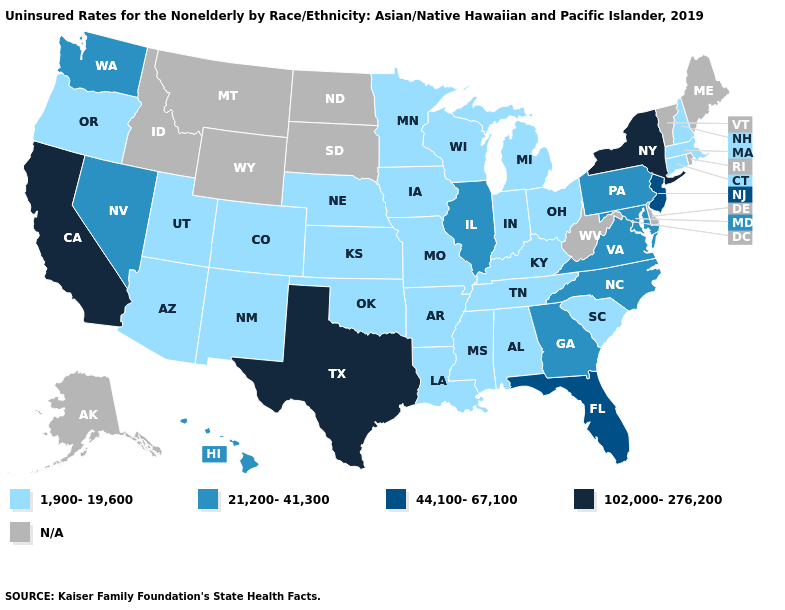Does New York have the highest value in the USA?
Quick response, please. Yes. Among the states that border New York , does Pennsylvania have the lowest value?
Answer briefly. No. What is the highest value in states that border Wyoming?
Quick response, please. 1,900-19,600. What is the value of Missouri?
Give a very brief answer. 1,900-19,600. Does New York have the highest value in the USA?
Write a very short answer. Yes. What is the value of Colorado?
Give a very brief answer. 1,900-19,600. What is the value of New York?
Quick response, please. 102,000-276,200. What is the value of North Dakota?
Answer briefly. N/A. Does the map have missing data?
Give a very brief answer. Yes. What is the highest value in the Northeast ?
Answer briefly. 102,000-276,200. Does Massachusetts have the highest value in the Northeast?
Write a very short answer. No. 